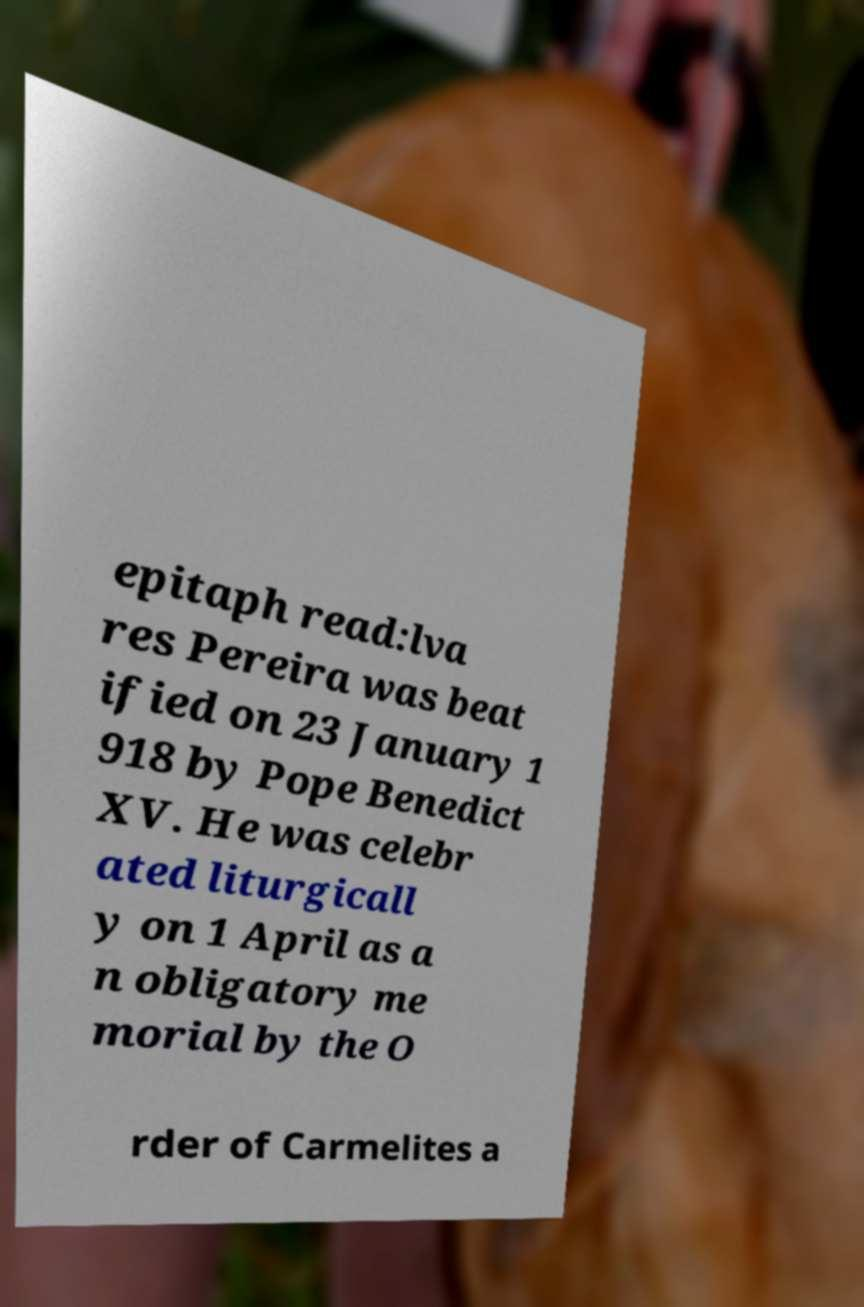I need the written content from this picture converted into text. Can you do that? epitaph read:lva res Pereira was beat ified on 23 January 1 918 by Pope Benedict XV. He was celebr ated liturgicall y on 1 April as a n obligatory me morial by the O rder of Carmelites a 